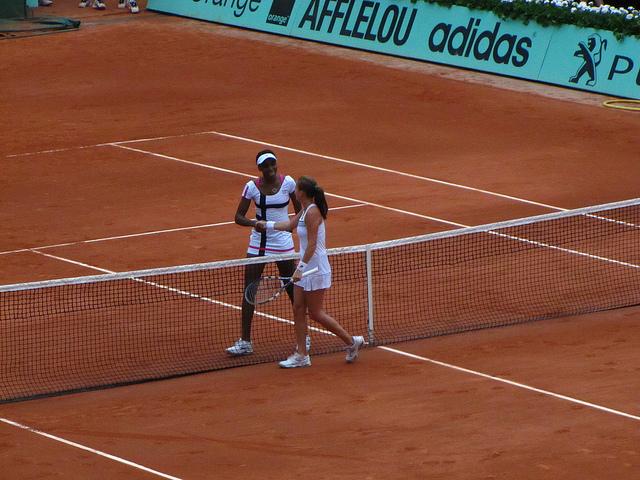What color is the court?
Keep it brief. Brown. What is the person holding?
Answer briefly. Tennis racket. What is the player holding in her right hand?
Answer briefly. Hand. Is the tennis game in progress?
Answer briefly. No. 